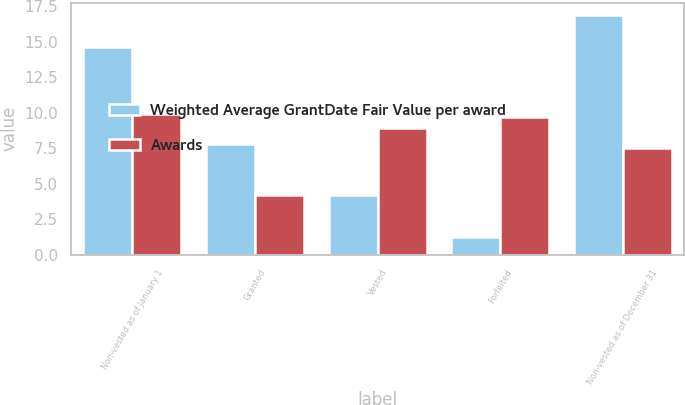Convert chart to OTSL. <chart><loc_0><loc_0><loc_500><loc_500><stacked_bar_chart><ecel><fcel>Non-vested as of January 1<fcel>Granted<fcel>Vested<fcel>Forfeited<fcel>Non-vested as of December 31<nl><fcel>Weighted Average GrantDate Fair Value per award<fcel>14.6<fcel>7.8<fcel>4.2<fcel>1.3<fcel>16.9<nl><fcel>Awards<fcel>9.92<fcel>4.21<fcel>8.93<fcel>9.71<fcel>7.55<nl></chart> 